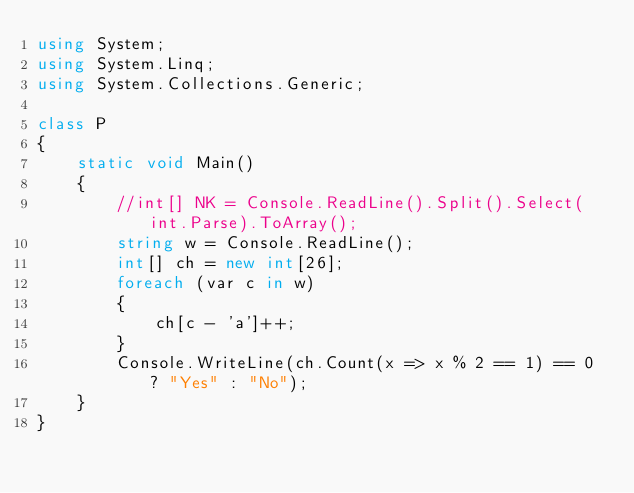Convert code to text. <code><loc_0><loc_0><loc_500><loc_500><_C#_>using System;
using System.Linq;
using System.Collections.Generic;

class P
{
    static void Main()
    {
        //int[] NK = Console.ReadLine().Split().Select(int.Parse).ToArray();
        string w = Console.ReadLine();
        int[] ch = new int[26];
        foreach (var c in w)
        {
            ch[c - 'a']++;
        }
        Console.WriteLine(ch.Count(x => x % 2 == 1) == 0 ? "Yes" : "No");
    }
}</code> 